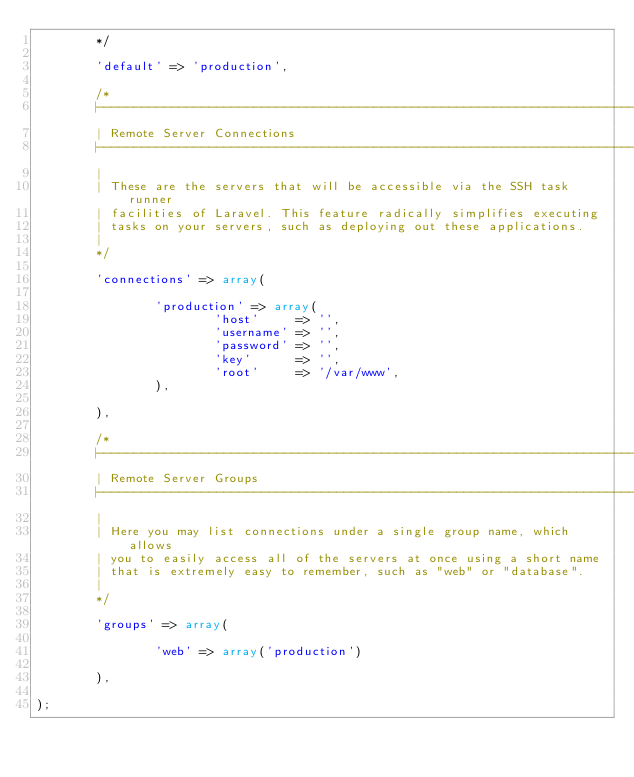Convert code to text. <code><loc_0><loc_0><loc_500><loc_500><_PHP_>        */

        'default' => 'production',

        /*
        |--------------------------------------------------------------------------
        | Remote Server Connections
        |--------------------------------------------------------------------------
        |
        | These are the servers that will be accessible via the SSH task runner
        | facilities of Laravel. This feature radically simplifies executing
        | tasks on your servers, such as deploying out these applications.
        |
        */

        'connections' => array(

                'production' => array(
                        'host'     => '',
                        'username' => '',
                        'password' => '',
                        'key'      => '',
                        'root'     => '/var/www',
                ),

        ),

        /*
        |--------------------------------------------------------------------------
        | Remote Server Groups
        |--------------------------------------------------------------------------
        |
        | Here you may list connections under a single group name, which allows
        | you to easily access all of the servers at once using a short name
        | that is extremely easy to remember, such as "web" or "database".
        |
        */

        'groups' => array(

                'web' => array('production')

        ),

);
</code> 